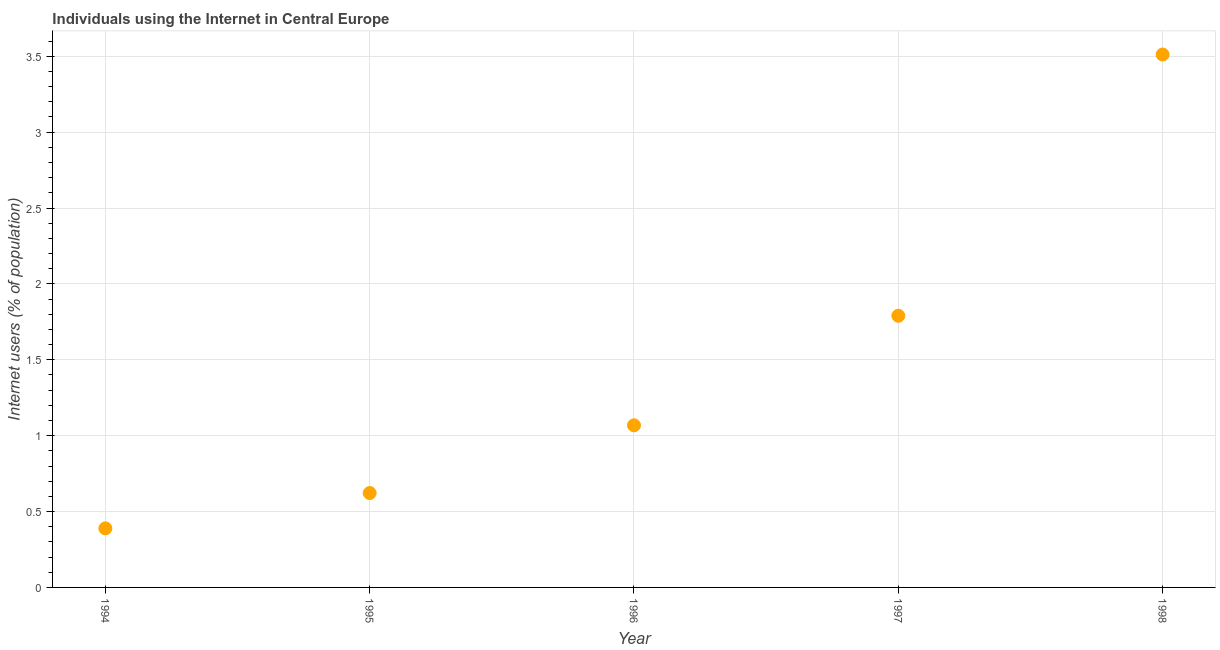What is the number of internet users in 1995?
Your answer should be very brief. 0.62. Across all years, what is the maximum number of internet users?
Provide a succinct answer. 3.51. Across all years, what is the minimum number of internet users?
Make the answer very short. 0.39. In which year was the number of internet users maximum?
Provide a short and direct response. 1998. In which year was the number of internet users minimum?
Ensure brevity in your answer.  1994. What is the sum of the number of internet users?
Your answer should be very brief. 7.38. What is the difference between the number of internet users in 1996 and 1998?
Your answer should be compact. -2.44. What is the average number of internet users per year?
Give a very brief answer. 1.48. What is the median number of internet users?
Provide a succinct answer. 1.07. In how many years, is the number of internet users greater than 3.4 %?
Ensure brevity in your answer.  1. What is the ratio of the number of internet users in 1994 to that in 1997?
Offer a very short reply. 0.22. Is the number of internet users in 1994 less than that in 1997?
Give a very brief answer. Yes. What is the difference between the highest and the second highest number of internet users?
Your answer should be compact. 1.72. Is the sum of the number of internet users in 1995 and 1997 greater than the maximum number of internet users across all years?
Make the answer very short. No. What is the difference between the highest and the lowest number of internet users?
Provide a short and direct response. 3.12. Does the number of internet users monotonically increase over the years?
Give a very brief answer. Yes. How many dotlines are there?
Provide a short and direct response. 1. How many years are there in the graph?
Provide a succinct answer. 5. What is the difference between two consecutive major ticks on the Y-axis?
Give a very brief answer. 0.5. Are the values on the major ticks of Y-axis written in scientific E-notation?
Offer a terse response. No. What is the title of the graph?
Give a very brief answer. Individuals using the Internet in Central Europe. What is the label or title of the X-axis?
Offer a terse response. Year. What is the label or title of the Y-axis?
Provide a short and direct response. Internet users (% of population). What is the Internet users (% of population) in 1994?
Make the answer very short. 0.39. What is the Internet users (% of population) in 1995?
Your answer should be compact. 0.62. What is the Internet users (% of population) in 1996?
Your answer should be compact. 1.07. What is the Internet users (% of population) in 1997?
Your response must be concise. 1.79. What is the Internet users (% of population) in 1998?
Keep it short and to the point. 3.51. What is the difference between the Internet users (% of population) in 1994 and 1995?
Make the answer very short. -0.23. What is the difference between the Internet users (% of population) in 1994 and 1996?
Keep it short and to the point. -0.68. What is the difference between the Internet users (% of population) in 1994 and 1997?
Offer a terse response. -1.4. What is the difference between the Internet users (% of population) in 1994 and 1998?
Give a very brief answer. -3.12. What is the difference between the Internet users (% of population) in 1995 and 1996?
Keep it short and to the point. -0.45. What is the difference between the Internet users (% of population) in 1995 and 1997?
Ensure brevity in your answer.  -1.17. What is the difference between the Internet users (% of population) in 1995 and 1998?
Your response must be concise. -2.89. What is the difference between the Internet users (% of population) in 1996 and 1997?
Offer a very short reply. -0.72. What is the difference between the Internet users (% of population) in 1996 and 1998?
Provide a succinct answer. -2.44. What is the difference between the Internet users (% of population) in 1997 and 1998?
Keep it short and to the point. -1.72. What is the ratio of the Internet users (% of population) in 1994 to that in 1995?
Keep it short and to the point. 0.63. What is the ratio of the Internet users (% of population) in 1994 to that in 1996?
Keep it short and to the point. 0.36. What is the ratio of the Internet users (% of population) in 1994 to that in 1997?
Your response must be concise. 0.22. What is the ratio of the Internet users (% of population) in 1994 to that in 1998?
Ensure brevity in your answer.  0.11. What is the ratio of the Internet users (% of population) in 1995 to that in 1996?
Your answer should be compact. 0.58. What is the ratio of the Internet users (% of population) in 1995 to that in 1997?
Keep it short and to the point. 0.35. What is the ratio of the Internet users (% of population) in 1995 to that in 1998?
Keep it short and to the point. 0.18. What is the ratio of the Internet users (% of population) in 1996 to that in 1997?
Your response must be concise. 0.6. What is the ratio of the Internet users (% of population) in 1996 to that in 1998?
Give a very brief answer. 0.3. What is the ratio of the Internet users (% of population) in 1997 to that in 1998?
Make the answer very short. 0.51. 